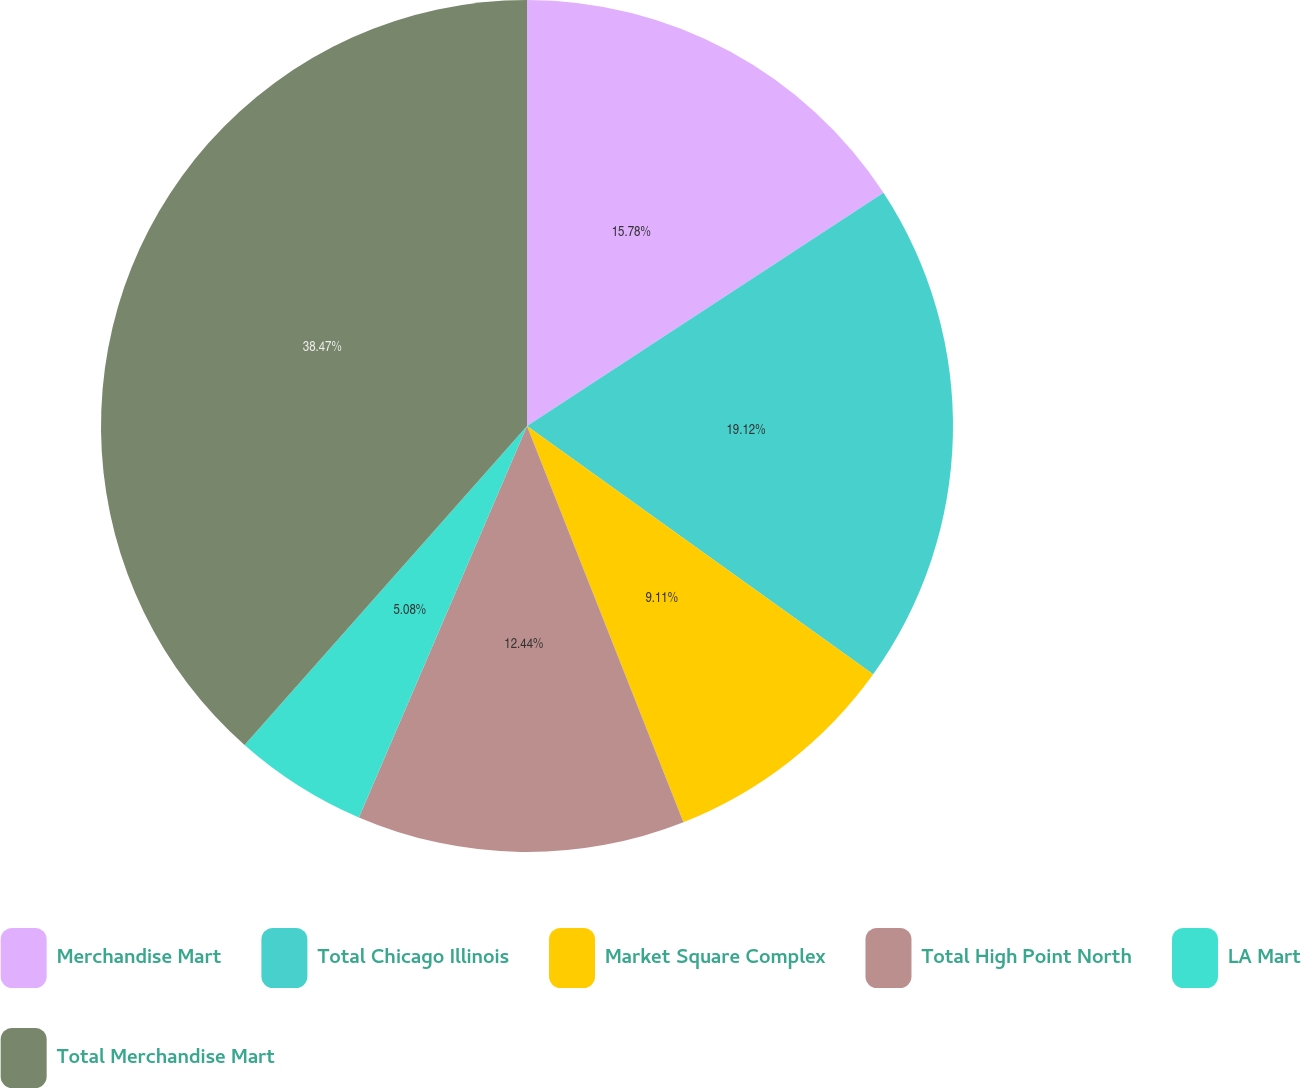Convert chart. <chart><loc_0><loc_0><loc_500><loc_500><pie_chart><fcel>Merchandise Mart<fcel>Total Chicago Illinois<fcel>Market Square Complex<fcel>Total High Point North<fcel>LA Mart<fcel>Total Merchandise Mart<nl><fcel>15.78%<fcel>19.12%<fcel>9.11%<fcel>12.44%<fcel>5.08%<fcel>38.46%<nl></chart> 